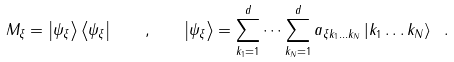Convert formula to latex. <formula><loc_0><loc_0><loc_500><loc_500>M _ { \xi } = \left | \psi _ { \xi } \right \rangle \left \langle \psi _ { \xi } \right | \quad , \quad \left | \psi _ { \xi } \right \rangle = \sum _ { k _ { 1 } = 1 } ^ { d } \dots \sum _ { k _ { N } = 1 } ^ { d } a _ { \xi k _ { 1 } \dots k _ { N } } \left | k _ { 1 } \dots k _ { N } \right \rangle \ .</formula> 